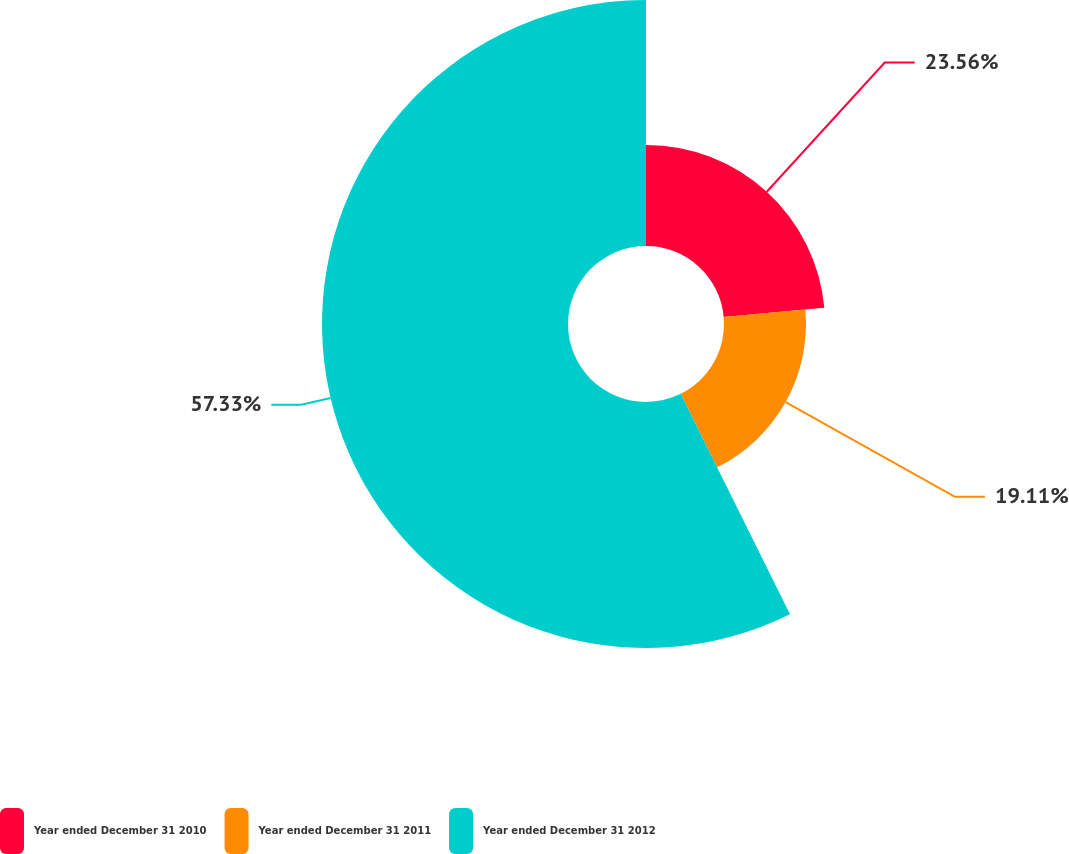Convert chart to OTSL. <chart><loc_0><loc_0><loc_500><loc_500><pie_chart><fcel>Year ended December 31 2010<fcel>Year ended December 31 2011<fcel>Year ended December 31 2012<nl><fcel>23.56%<fcel>19.11%<fcel>57.33%<nl></chart> 